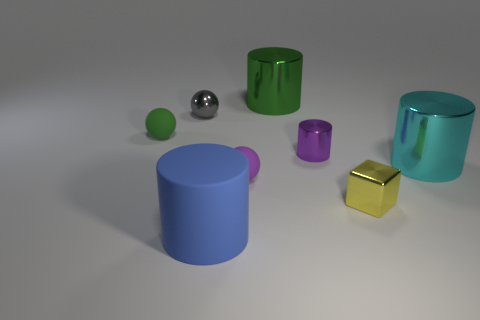There is a tiny purple thing that is the same material as the big blue thing; what is its shape?
Keep it short and to the point. Sphere. There is a matte thing that is in front of the tiny cube; is its shape the same as the purple metal thing?
Give a very brief answer. Yes. How many brown things are either big metal cylinders or objects?
Offer a terse response. 0. Is the number of small metal things right of the tiny gray metallic ball the same as the number of small metal cylinders in front of the tiny yellow shiny thing?
Offer a terse response. No. There is a large cylinder that is on the left side of the tiny purple thing on the left side of the big cylinder that is behind the green ball; what is its color?
Offer a very short reply. Blue. Is there anything else that has the same color as the small metal cylinder?
Provide a short and direct response. Yes. What is the size of the metallic thing on the left side of the big blue object?
Keep it short and to the point. Small. The purple metal object that is the same size as the gray thing is what shape?
Your answer should be compact. Cylinder. Are the small gray thing behind the big cyan metallic thing and the yellow object that is left of the big cyan thing made of the same material?
Offer a terse response. Yes. What material is the purple object behind the metal cylinder to the right of the tiny cube?
Provide a succinct answer. Metal. 